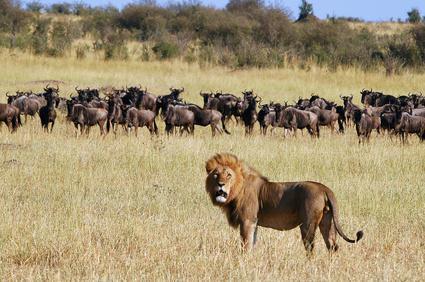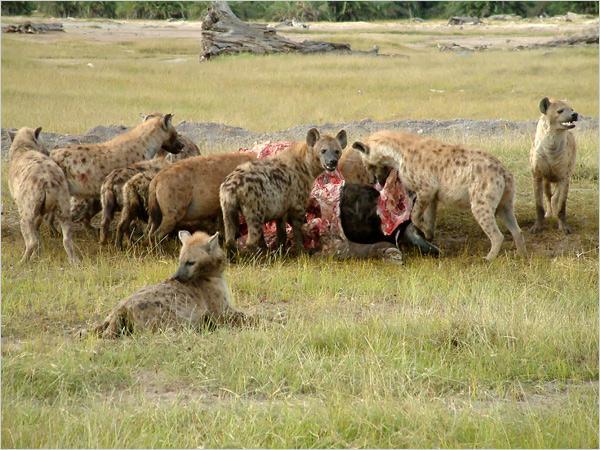The first image is the image on the left, the second image is the image on the right. For the images displayed, is the sentence "A lion is with a group of hyenas in at least one of the images." factually correct? Answer yes or no. Yes. The first image is the image on the left, the second image is the image on the right. Given the left and right images, does the statement "One image contains at least one lion." hold true? Answer yes or no. Yes. 